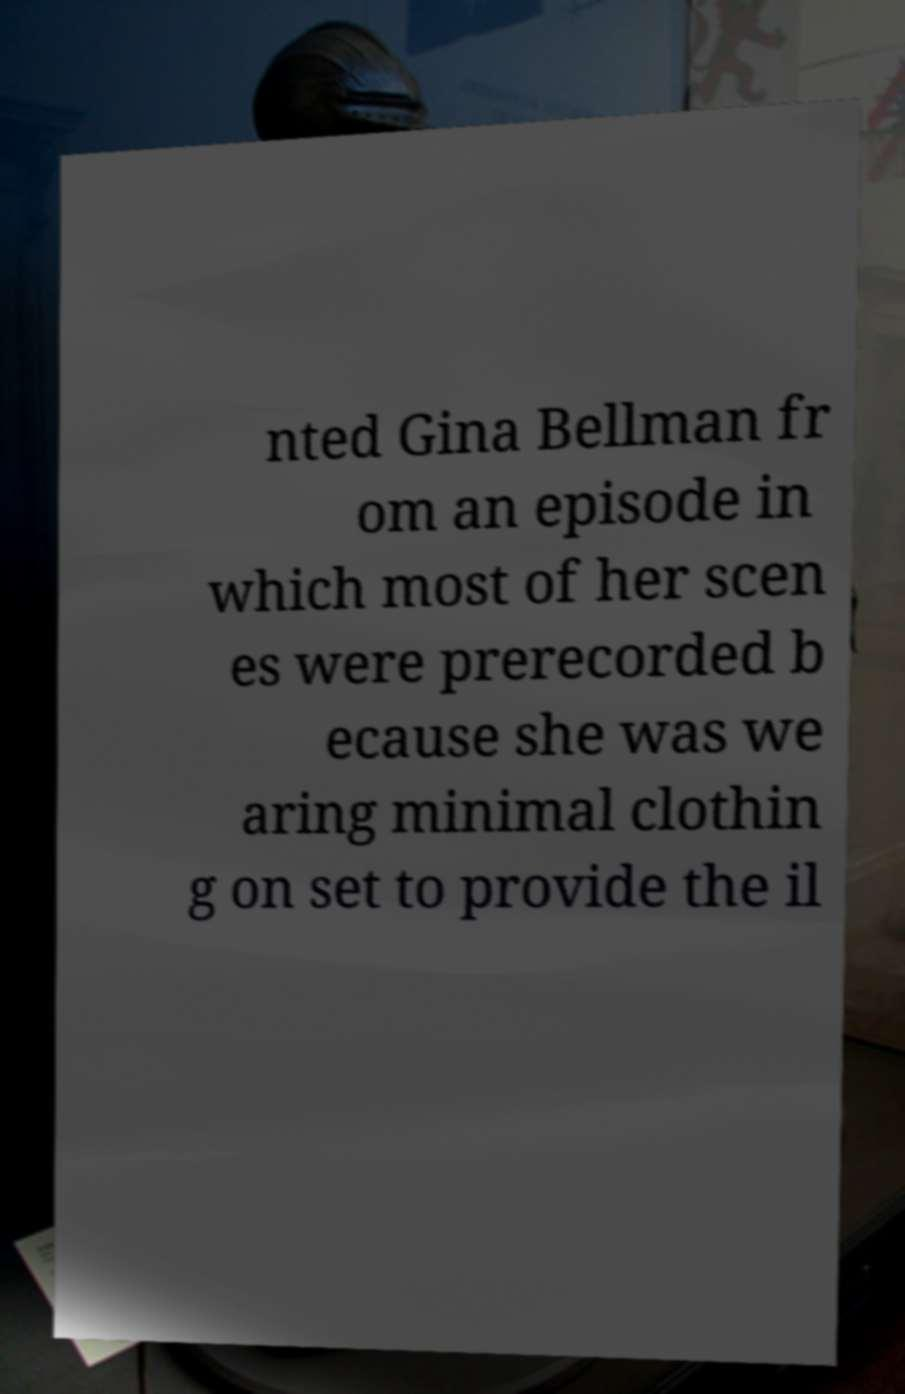Please read and relay the text visible in this image. What does it say? nted Gina Bellman fr om an episode in which most of her scen es were prerecorded b ecause she was we aring minimal clothin g on set to provide the il 